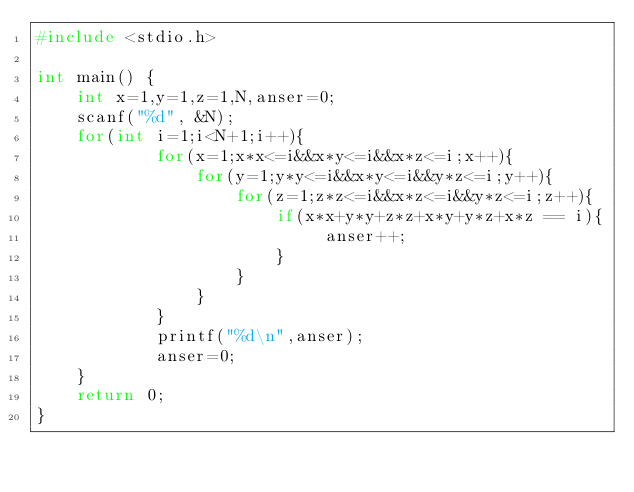Convert code to text. <code><loc_0><loc_0><loc_500><loc_500><_C_>#include <stdio.h>

int main() {
    int x=1,y=1,z=1,N,anser=0;
    scanf("%d", &N);
    for(int i=1;i<N+1;i++){
            for(x=1;x*x<=i&&x*y<=i&&x*z<=i;x++){
                for(y=1;y*y<=i&&x*y<=i&&y*z<=i;y++){
                    for(z=1;z*z<=i&&x*z<=i&&y*z<=i;z++){
                        if(x*x+y*y+z*z+x*y+y*z+x*z == i){
                             anser++;    
                        }
                    }
                }
            }
            printf("%d\n",anser);
            anser=0;
    }
    return 0;
}
</code> 